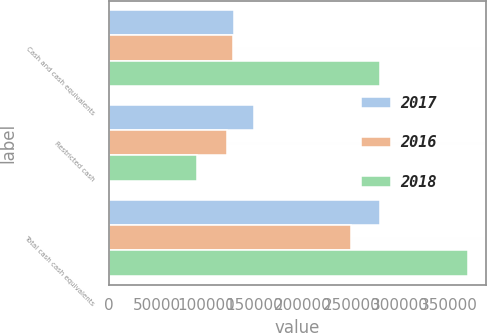Convert chart. <chart><loc_0><loc_0><loc_500><loc_500><stacked_bar_chart><ecel><fcel>Cash and cash equivalents<fcel>Restricted cash<fcel>Total cash cash equivalents<nl><fcel>2017<fcel>129475<fcel>149638<fcel>279113<nl><fcel>2016<fcel>127888<fcel>122138<fcel>250026<nl><fcel>2018<fcel>279443<fcel>90524<fcel>369967<nl></chart> 